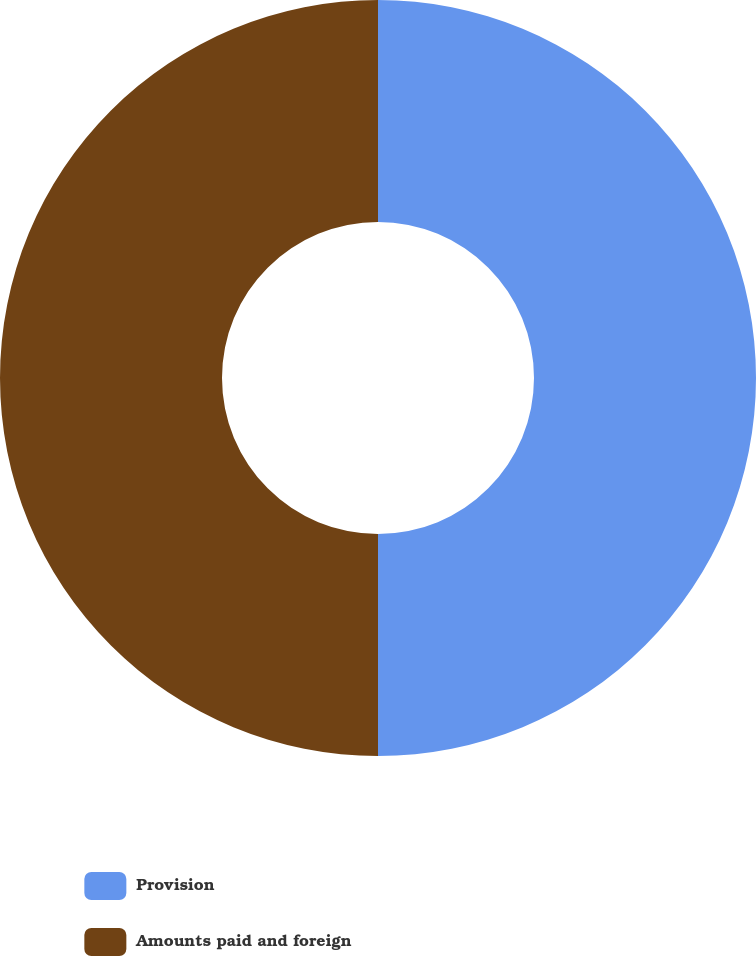Convert chart. <chart><loc_0><loc_0><loc_500><loc_500><pie_chart><fcel>Provision<fcel>Amounts paid and foreign<nl><fcel>50.0%<fcel>50.0%<nl></chart> 